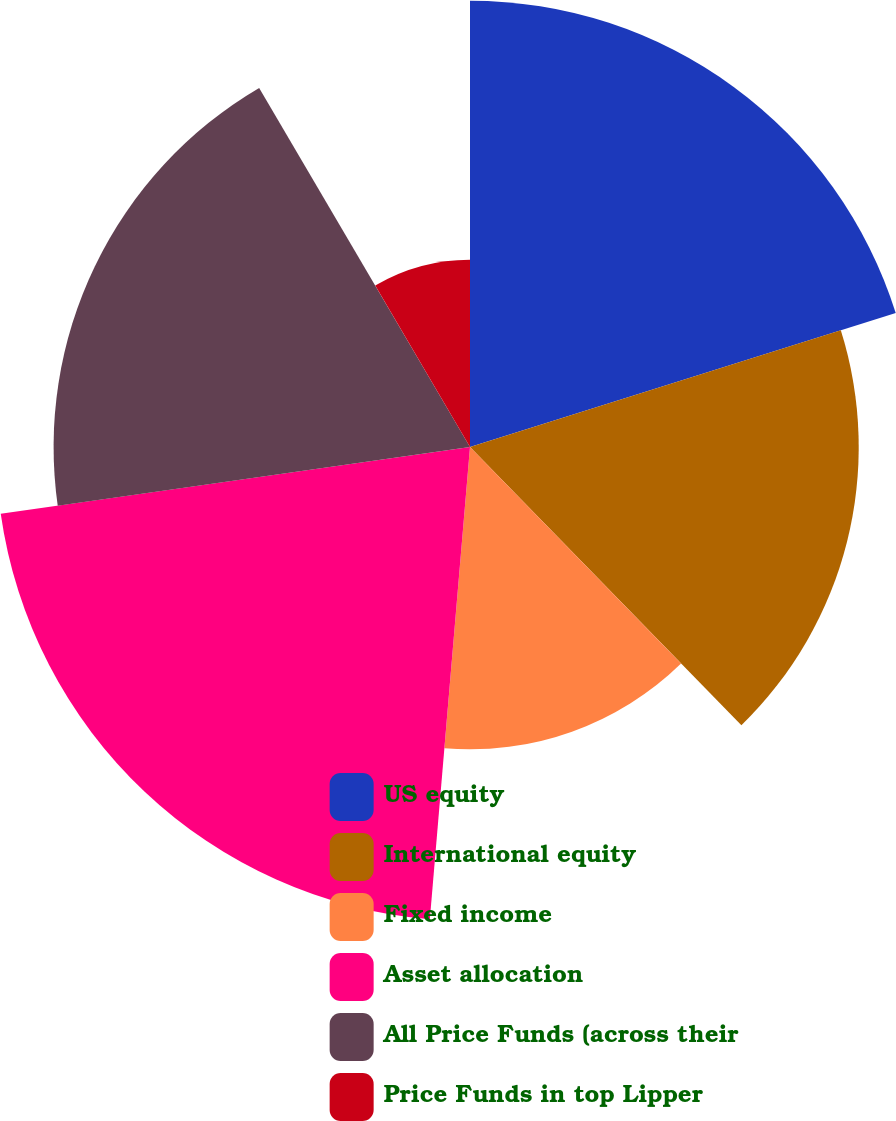Convert chart to OTSL. <chart><loc_0><loc_0><loc_500><loc_500><pie_chart><fcel>US equity<fcel>International equity<fcel>Fixed income<fcel>Asset allocation<fcel>All Price Funds (across their<fcel>Price Funds in top Lipper<nl><fcel>20.15%<fcel>17.55%<fcel>13.65%<fcel>21.4%<fcel>18.8%<fcel>8.45%<nl></chart> 